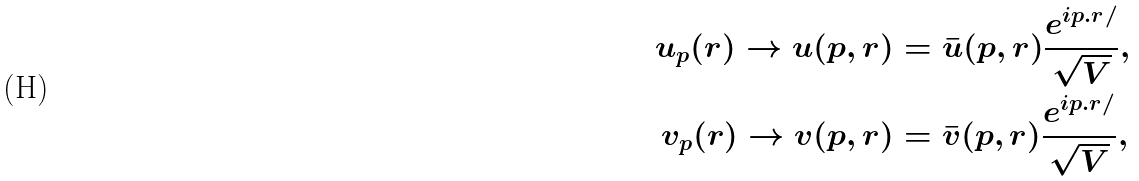<formula> <loc_0><loc_0><loc_500><loc_500>u _ { p } ( r ) \rightarrow u ( p , r ) & = \bar { u } ( p , r ) \frac { e ^ { i p . r / } } { \sqrt { V } } , \\ v _ { p } ( r ) \rightarrow v ( p , r ) & = \bar { v } ( p , r ) \frac { e ^ { i p . r / } } { \sqrt { V } } ,</formula> 